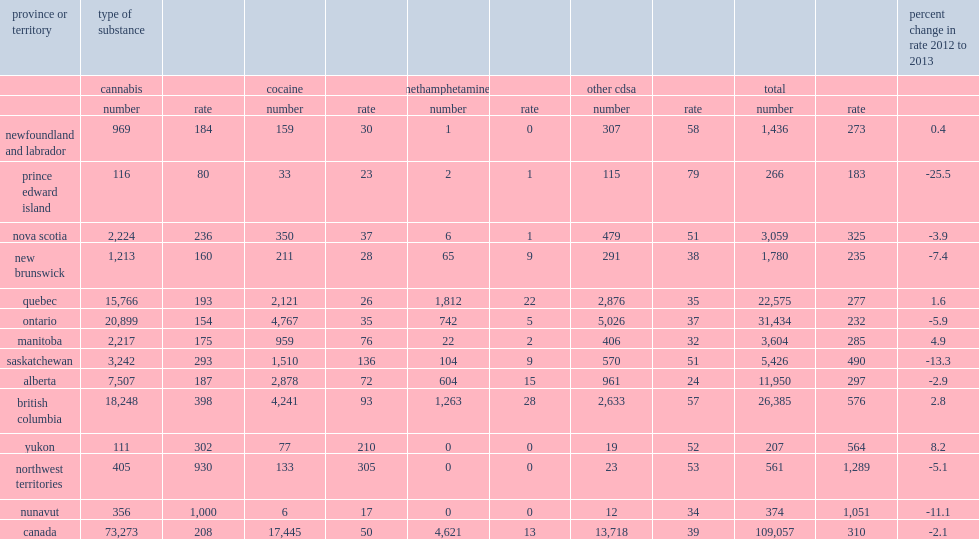In 2013, what is the percentage of the decrease in the rate of drug offences of the police-reported in saskatchewan? 13.3. In 2013, what is the percentage of the increase in the rate of drug offences of the police-reported in british columbia? 2.8. In 2013, how many violations in british columbia having the police-reported drug offence per 100,000? 576.0. In 2013, what is the rate of the northwest territories had police-reported drug offence? 1289.0. In 2013, what is the rate of the nunavut had police-reported drug offence? 1051.0. What is the rate of police-reported drug offences in yukon? 564.0. 